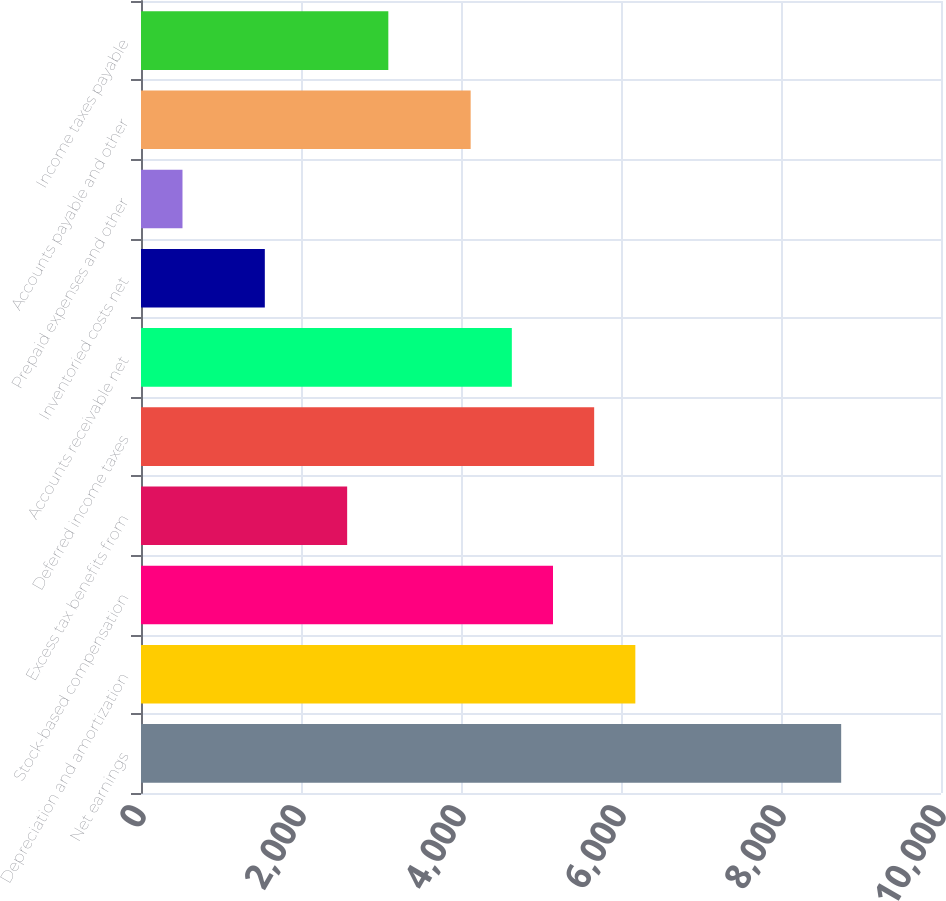Convert chart. <chart><loc_0><loc_0><loc_500><loc_500><bar_chart><fcel>Net earnings<fcel>Depreciation and amortization<fcel>Stock-based compensation<fcel>Excess tax benefits from<fcel>Deferred income taxes<fcel>Accounts receivable net<fcel>Inventoried costs net<fcel>Prepaid expenses and other<fcel>Accounts payable and other<fcel>Income taxes payable<nl><fcel>8752.2<fcel>6179.2<fcel>5150<fcel>2577<fcel>5664.6<fcel>4635.4<fcel>1547.8<fcel>518.6<fcel>4120.8<fcel>3091.6<nl></chart> 